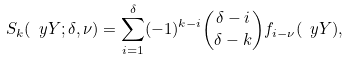<formula> <loc_0><loc_0><loc_500><loc_500>S _ { k } ( \ y Y ; \delta , \nu ) = \sum _ { i = 1 } ^ { \delta } ( - 1 ) ^ { k - i } \binom { \delta - i } { \delta - k } f _ { i - \nu } ( \ y Y ) ,</formula> 